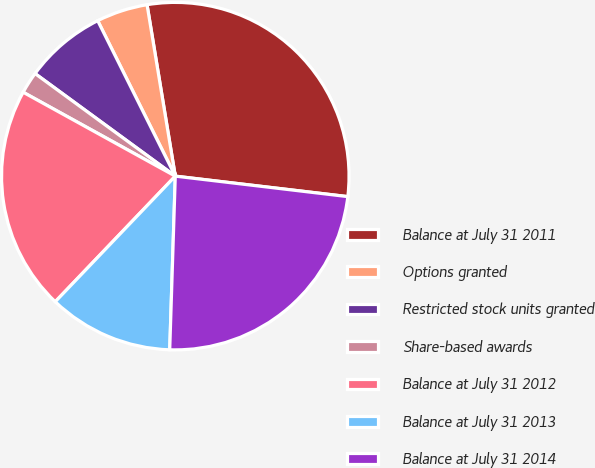<chart> <loc_0><loc_0><loc_500><loc_500><pie_chart><fcel>Balance at July 31 2011<fcel>Options granted<fcel>Restricted stock units granted<fcel>Share-based awards<fcel>Balance at July 31 2012<fcel>Balance at July 31 2013<fcel>Balance at July 31 2014<nl><fcel>29.48%<fcel>4.77%<fcel>7.58%<fcel>2.03%<fcel>20.88%<fcel>11.63%<fcel>23.63%<nl></chart> 